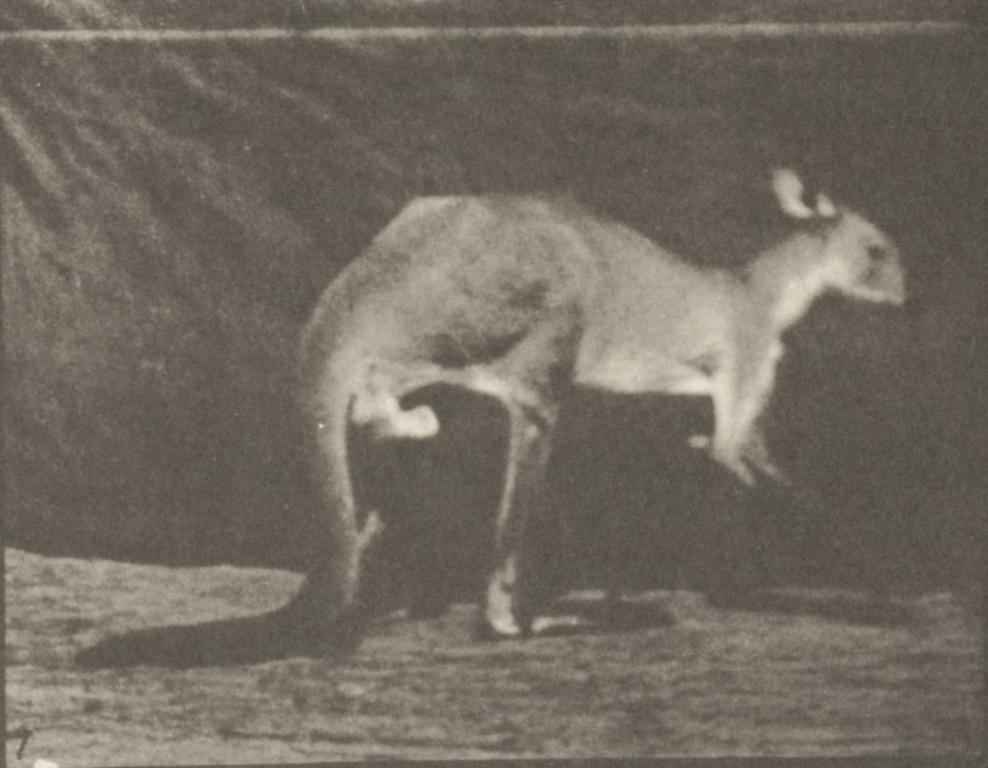What is the color scheme of the photograph? The photograph is black and white. What animal is the main subject of the photograph? The subject of the photograph is a kangaroo. What is the kangaroo's position in the photograph? The kangaroo is standing on the ground. What can be seen behind the kangaroo in the photograph? There is a black background in the photograph. How many tins are visible in the photograph? There are no tins present in the photograph; it features a kangaroo standing on the ground with a black background. What type of sack is the kangaroo carrying in the photograph? There is no sack present in the photograph; the kangaroo is not carrying anything. 